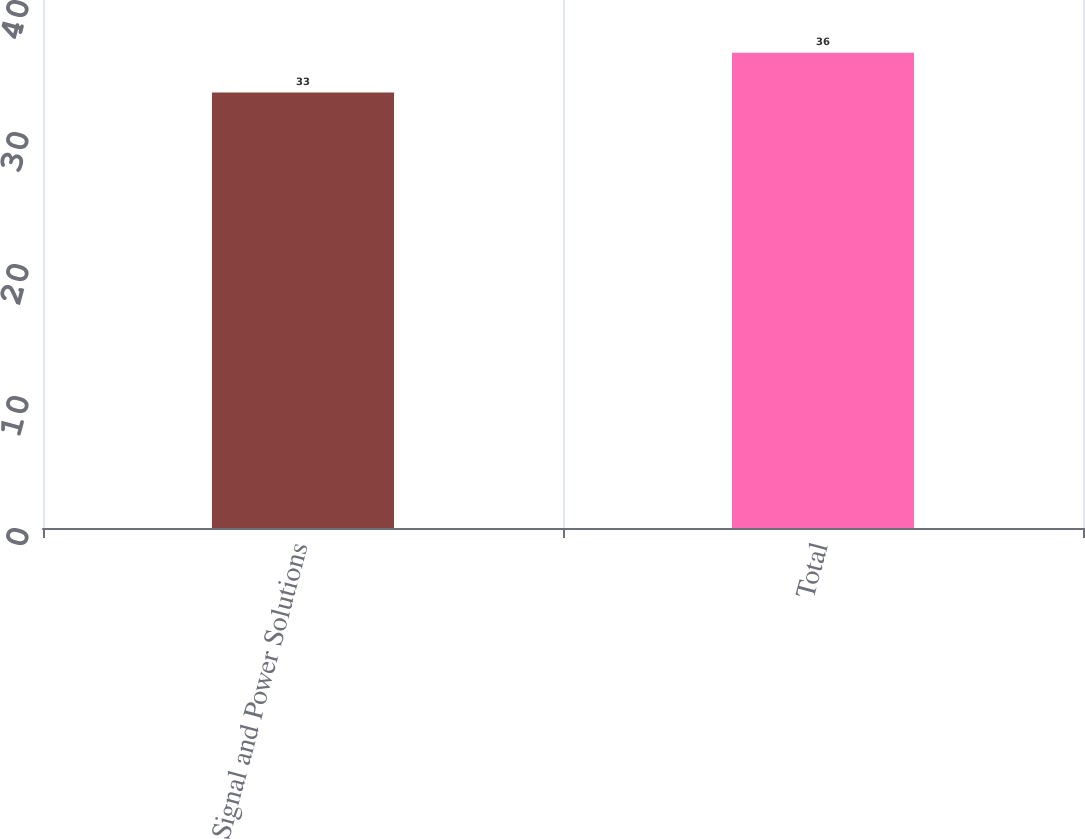Convert chart to OTSL. <chart><loc_0><loc_0><loc_500><loc_500><bar_chart><fcel>Signal and Power Solutions<fcel>Total<nl><fcel>33<fcel>36<nl></chart> 